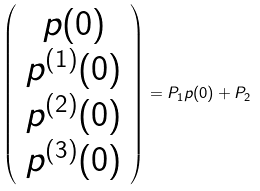Convert formula to latex. <formula><loc_0><loc_0><loc_500><loc_500>\left ( \begin{array} { c } p ( 0 ) \\ p ^ { ( 1 ) } ( 0 ) \\ p ^ { ( 2 ) } ( 0 ) \\ p ^ { ( 3 ) } ( 0 ) \end{array} \right ) = P _ { 1 } p ( 0 ) + P _ { 2 }</formula> 